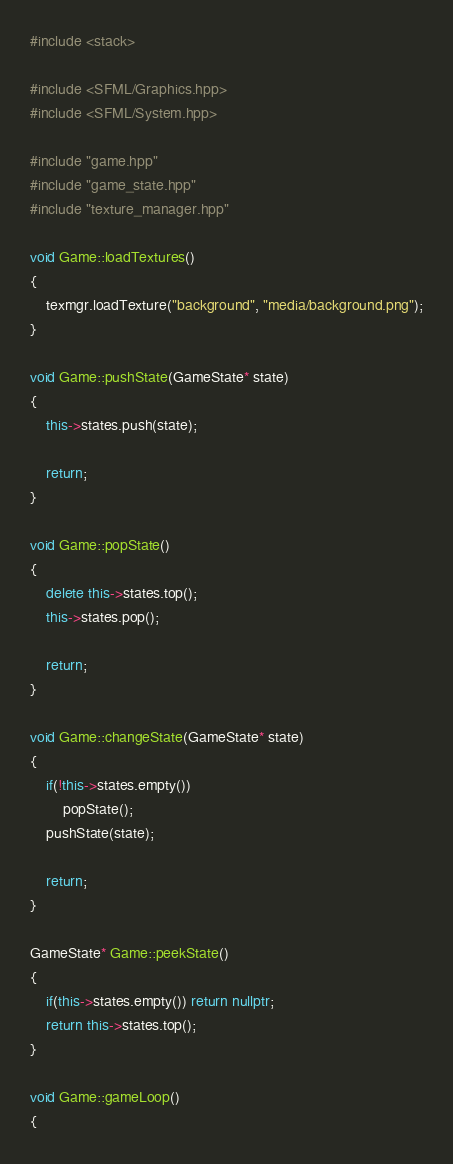<code> <loc_0><loc_0><loc_500><loc_500><_C++_>#include <stack>

#include <SFML/Graphics.hpp>
#include <SFML/System.hpp>

#include "game.hpp"
#include "game_state.hpp"
#include "texture_manager.hpp"

void Game::loadTextures()
{
    texmgr.loadTexture("background", "media/background.png");
}

void Game::pushState(GameState* state)
{
    this->states.push(state);

    return;
}

void Game::popState()
{
    delete this->states.top();
    this->states.pop();

    return;
}

void Game::changeState(GameState* state)
{
    if(!this->states.empty())
        popState();
    pushState(state);

    return;
}

GameState* Game::peekState()
{
    if(this->states.empty()) return nullptr;
    return this->states.top();
}

void Game::gameLoop()
{</code> 